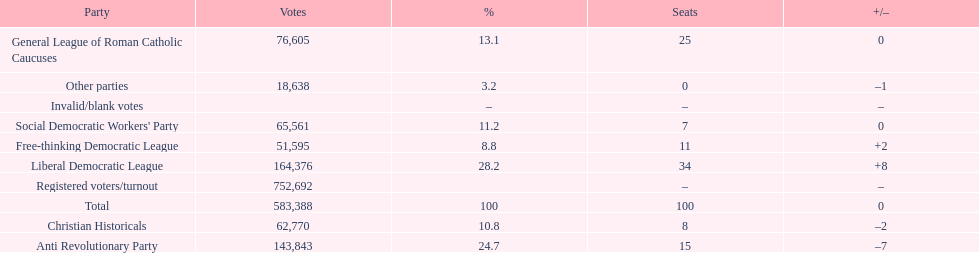After the election, how many seats did the liberal democratic league win? 34. 